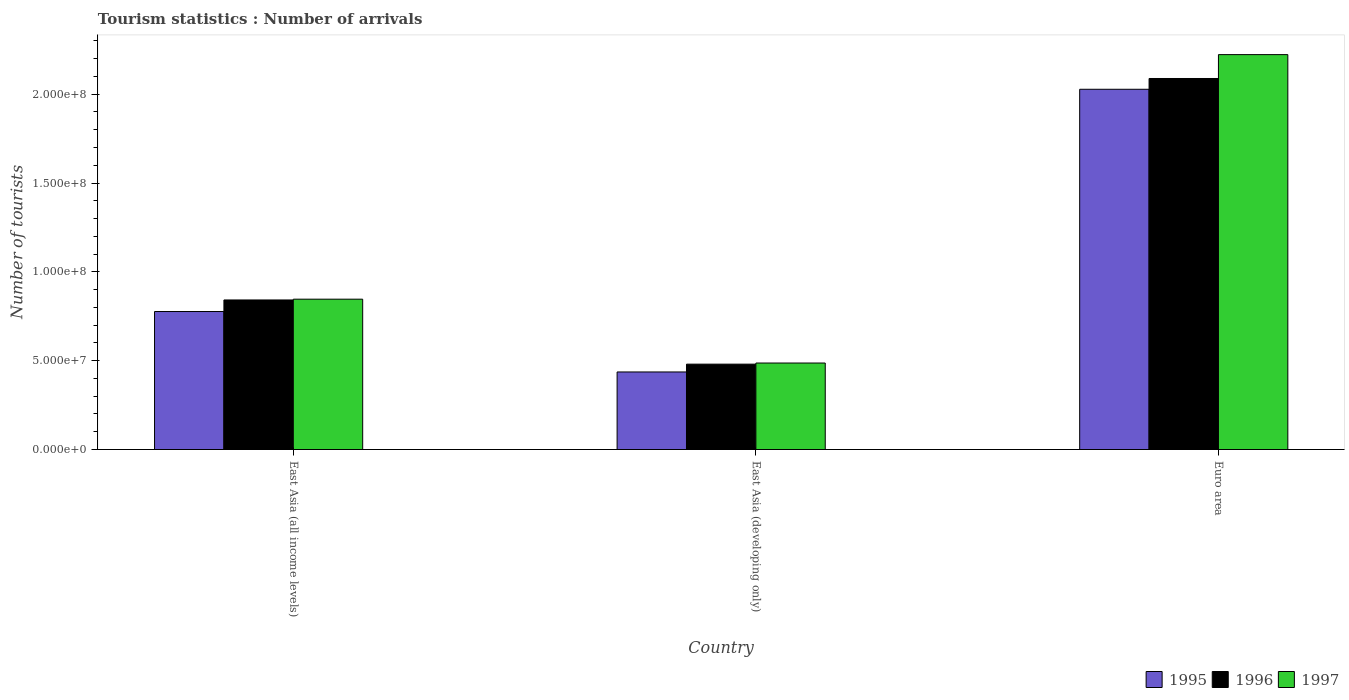How many groups of bars are there?
Your response must be concise. 3. How many bars are there on the 2nd tick from the left?
Your response must be concise. 3. What is the label of the 1st group of bars from the left?
Provide a short and direct response. East Asia (all income levels). In how many cases, is the number of bars for a given country not equal to the number of legend labels?
Give a very brief answer. 0. What is the number of tourist arrivals in 1996 in Euro area?
Your response must be concise. 2.09e+08. Across all countries, what is the maximum number of tourist arrivals in 1995?
Provide a succinct answer. 2.03e+08. Across all countries, what is the minimum number of tourist arrivals in 1995?
Offer a terse response. 4.36e+07. In which country was the number of tourist arrivals in 1996 maximum?
Provide a succinct answer. Euro area. In which country was the number of tourist arrivals in 1995 minimum?
Provide a succinct answer. East Asia (developing only). What is the total number of tourist arrivals in 1995 in the graph?
Your response must be concise. 3.24e+08. What is the difference between the number of tourist arrivals in 1995 in East Asia (all income levels) and that in East Asia (developing only)?
Provide a short and direct response. 3.40e+07. What is the difference between the number of tourist arrivals in 1997 in Euro area and the number of tourist arrivals in 1996 in East Asia (all income levels)?
Ensure brevity in your answer.  1.38e+08. What is the average number of tourist arrivals in 1995 per country?
Offer a terse response. 1.08e+08. What is the difference between the number of tourist arrivals of/in 1997 and number of tourist arrivals of/in 1996 in East Asia (developing only)?
Provide a succinct answer. 6.36e+05. In how many countries, is the number of tourist arrivals in 1996 greater than 120000000?
Offer a terse response. 1. What is the ratio of the number of tourist arrivals in 1995 in East Asia (all income levels) to that in East Asia (developing only)?
Your answer should be very brief. 1.78. What is the difference between the highest and the second highest number of tourist arrivals in 1997?
Give a very brief answer. 3.59e+07. What is the difference between the highest and the lowest number of tourist arrivals in 1995?
Your answer should be compact. 1.59e+08. Is the sum of the number of tourist arrivals in 1995 in East Asia (all income levels) and East Asia (developing only) greater than the maximum number of tourist arrivals in 1997 across all countries?
Provide a short and direct response. No. What does the 2nd bar from the right in East Asia (all income levels) represents?
Ensure brevity in your answer.  1996. What is the difference between two consecutive major ticks on the Y-axis?
Provide a succinct answer. 5.00e+07. Are the values on the major ticks of Y-axis written in scientific E-notation?
Offer a very short reply. Yes. Where does the legend appear in the graph?
Keep it short and to the point. Bottom right. How many legend labels are there?
Your response must be concise. 3. What is the title of the graph?
Your response must be concise. Tourism statistics : Number of arrivals. What is the label or title of the Y-axis?
Your answer should be very brief. Number of tourists. What is the Number of tourists in 1995 in East Asia (all income levels)?
Ensure brevity in your answer.  7.77e+07. What is the Number of tourists of 1996 in East Asia (all income levels)?
Your answer should be compact. 8.42e+07. What is the Number of tourists of 1997 in East Asia (all income levels)?
Offer a very short reply. 8.46e+07. What is the Number of tourists in 1995 in East Asia (developing only)?
Give a very brief answer. 4.36e+07. What is the Number of tourists of 1996 in East Asia (developing only)?
Make the answer very short. 4.80e+07. What is the Number of tourists of 1997 in East Asia (developing only)?
Your answer should be very brief. 4.87e+07. What is the Number of tourists of 1995 in Euro area?
Offer a terse response. 2.03e+08. What is the Number of tourists of 1996 in Euro area?
Ensure brevity in your answer.  2.09e+08. What is the Number of tourists of 1997 in Euro area?
Ensure brevity in your answer.  2.22e+08. Across all countries, what is the maximum Number of tourists in 1995?
Your answer should be compact. 2.03e+08. Across all countries, what is the maximum Number of tourists of 1996?
Keep it short and to the point. 2.09e+08. Across all countries, what is the maximum Number of tourists of 1997?
Offer a terse response. 2.22e+08. Across all countries, what is the minimum Number of tourists in 1995?
Offer a very short reply. 4.36e+07. Across all countries, what is the minimum Number of tourists in 1996?
Offer a terse response. 4.80e+07. Across all countries, what is the minimum Number of tourists in 1997?
Offer a terse response. 4.87e+07. What is the total Number of tourists in 1995 in the graph?
Provide a short and direct response. 3.24e+08. What is the total Number of tourists of 1996 in the graph?
Keep it short and to the point. 3.41e+08. What is the total Number of tourists of 1997 in the graph?
Offer a very short reply. 3.56e+08. What is the difference between the Number of tourists of 1995 in East Asia (all income levels) and that in East Asia (developing only)?
Your answer should be compact. 3.40e+07. What is the difference between the Number of tourists in 1996 in East Asia (all income levels) and that in East Asia (developing only)?
Make the answer very short. 3.61e+07. What is the difference between the Number of tourists of 1997 in East Asia (all income levels) and that in East Asia (developing only)?
Provide a short and direct response. 3.59e+07. What is the difference between the Number of tourists of 1995 in East Asia (all income levels) and that in Euro area?
Give a very brief answer. -1.25e+08. What is the difference between the Number of tourists in 1996 in East Asia (all income levels) and that in Euro area?
Keep it short and to the point. -1.25e+08. What is the difference between the Number of tourists of 1997 in East Asia (all income levels) and that in Euro area?
Your response must be concise. -1.38e+08. What is the difference between the Number of tourists in 1995 in East Asia (developing only) and that in Euro area?
Keep it short and to the point. -1.59e+08. What is the difference between the Number of tourists in 1996 in East Asia (developing only) and that in Euro area?
Make the answer very short. -1.61e+08. What is the difference between the Number of tourists in 1997 in East Asia (developing only) and that in Euro area?
Your answer should be very brief. -1.74e+08. What is the difference between the Number of tourists in 1995 in East Asia (all income levels) and the Number of tourists in 1996 in East Asia (developing only)?
Provide a short and direct response. 2.96e+07. What is the difference between the Number of tourists of 1995 in East Asia (all income levels) and the Number of tourists of 1997 in East Asia (developing only)?
Offer a very short reply. 2.90e+07. What is the difference between the Number of tourists in 1996 in East Asia (all income levels) and the Number of tourists in 1997 in East Asia (developing only)?
Offer a terse response. 3.55e+07. What is the difference between the Number of tourists in 1995 in East Asia (all income levels) and the Number of tourists in 1996 in Euro area?
Make the answer very short. -1.31e+08. What is the difference between the Number of tourists in 1995 in East Asia (all income levels) and the Number of tourists in 1997 in Euro area?
Provide a succinct answer. -1.45e+08. What is the difference between the Number of tourists in 1996 in East Asia (all income levels) and the Number of tourists in 1997 in Euro area?
Keep it short and to the point. -1.38e+08. What is the difference between the Number of tourists in 1995 in East Asia (developing only) and the Number of tourists in 1996 in Euro area?
Ensure brevity in your answer.  -1.65e+08. What is the difference between the Number of tourists of 1995 in East Asia (developing only) and the Number of tourists of 1997 in Euro area?
Offer a very short reply. -1.79e+08. What is the difference between the Number of tourists of 1996 in East Asia (developing only) and the Number of tourists of 1997 in Euro area?
Give a very brief answer. -1.74e+08. What is the average Number of tourists in 1995 per country?
Keep it short and to the point. 1.08e+08. What is the average Number of tourists in 1996 per country?
Offer a terse response. 1.14e+08. What is the average Number of tourists of 1997 per country?
Provide a succinct answer. 1.19e+08. What is the difference between the Number of tourists in 1995 and Number of tourists in 1996 in East Asia (all income levels)?
Your answer should be very brief. -6.50e+06. What is the difference between the Number of tourists in 1995 and Number of tourists in 1997 in East Asia (all income levels)?
Offer a terse response. -6.94e+06. What is the difference between the Number of tourists of 1996 and Number of tourists of 1997 in East Asia (all income levels)?
Offer a very short reply. -4.38e+05. What is the difference between the Number of tourists of 1995 and Number of tourists of 1996 in East Asia (developing only)?
Provide a short and direct response. -4.40e+06. What is the difference between the Number of tourists in 1995 and Number of tourists in 1997 in East Asia (developing only)?
Your response must be concise. -5.03e+06. What is the difference between the Number of tourists of 1996 and Number of tourists of 1997 in East Asia (developing only)?
Ensure brevity in your answer.  -6.36e+05. What is the difference between the Number of tourists of 1995 and Number of tourists of 1996 in Euro area?
Offer a terse response. -6.07e+06. What is the difference between the Number of tourists in 1995 and Number of tourists in 1997 in Euro area?
Provide a succinct answer. -1.95e+07. What is the difference between the Number of tourists in 1996 and Number of tourists in 1997 in Euro area?
Provide a succinct answer. -1.34e+07. What is the ratio of the Number of tourists in 1995 in East Asia (all income levels) to that in East Asia (developing only)?
Your answer should be very brief. 1.78. What is the ratio of the Number of tourists in 1996 in East Asia (all income levels) to that in East Asia (developing only)?
Your response must be concise. 1.75. What is the ratio of the Number of tourists of 1997 in East Asia (all income levels) to that in East Asia (developing only)?
Your response must be concise. 1.74. What is the ratio of the Number of tourists in 1995 in East Asia (all income levels) to that in Euro area?
Offer a very short reply. 0.38. What is the ratio of the Number of tourists in 1996 in East Asia (all income levels) to that in Euro area?
Provide a short and direct response. 0.4. What is the ratio of the Number of tourists in 1997 in East Asia (all income levels) to that in Euro area?
Give a very brief answer. 0.38. What is the ratio of the Number of tourists in 1995 in East Asia (developing only) to that in Euro area?
Keep it short and to the point. 0.22. What is the ratio of the Number of tourists of 1996 in East Asia (developing only) to that in Euro area?
Give a very brief answer. 0.23. What is the ratio of the Number of tourists in 1997 in East Asia (developing only) to that in Euro area?
Give a very brief answer. 0.22. What is the difference between the highest and the second highest Number of tourists of 1995?
Provide a short and direct response. 1.25e+08. What is the difference between the highest and the second highest Number of tourists of 1996?
Your response must be concise. 1.25e+08. What is the difference between the highest and the second highest Number of tourists of 1997?
Ensure brevity in your answer.  1.38e+08. What is the difference between the highest and the lowest Number of tourists in 1995?
Your answer should be very brief. 1.59e+08. What is the difference between the highest and the lowest Number of tourists of 1996?
Your response must be concise. 1.61e+08. What is the difference between the highest and the lowest Number of tourists in 1997?
Provide a short and direct response. 1.74e+08. 